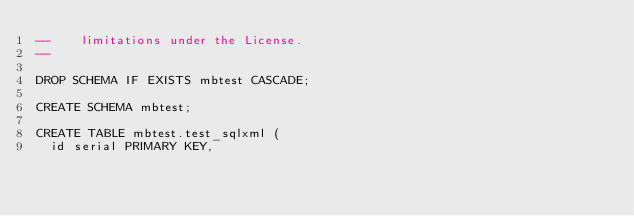<code> <loc_0><loc_0><loc_500><loc_500><_SQL_>--    limitations under the License.
--

DROP SCHEMA IF EXISTS mbtest CASCADE;

CREATE SCHEMA mbtest;

CREATE TABLE mbtest.test_sqlxml (
  id serial PRIMARY KEY,</code> 